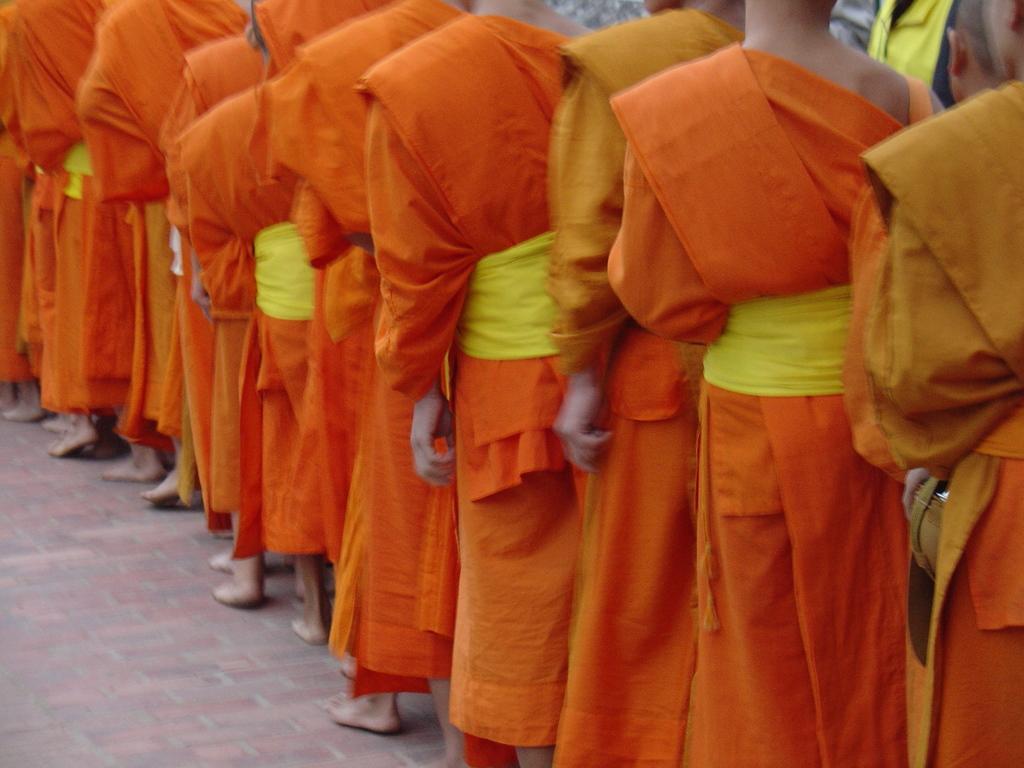Please provide a concise description of this image. In the image there are many persons standing in line on the floor, they all wore orange color dress, they seems to be monks. 